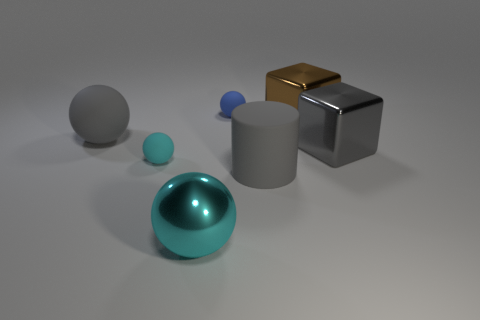There is a brown object that is to the right of the blue rubber thing; how many brown blocks are right of it? 0 